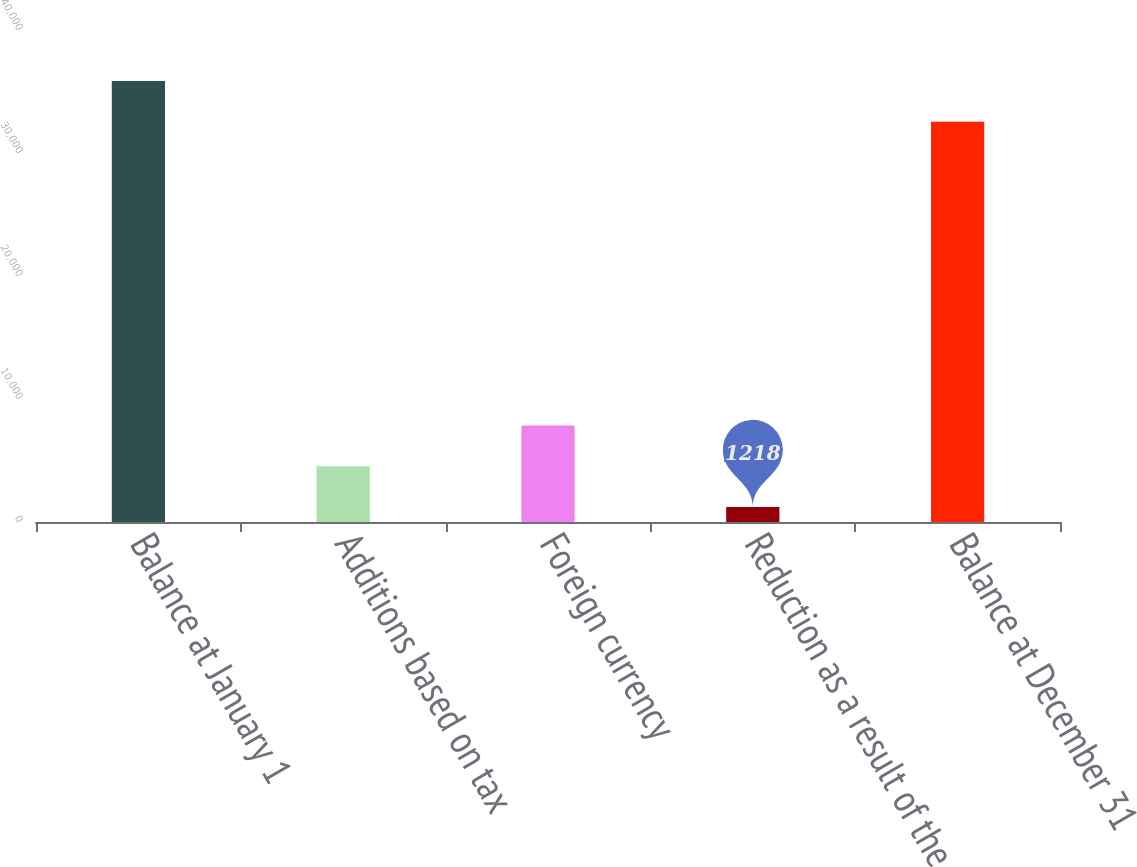<chart> <loc_0><loc_0><loc_500><loc_500><bar_chart><fcel>Balance at January 1<fcel>Additions based on tax<fcel>Foreign currency<fcel>Reduction as a result of the<fcel>Balance at December 31<nl><fcel>35856.9<fcel>4529.9<fcel>7841.8<fcel>1218<fcel>32545<nl></chart> 